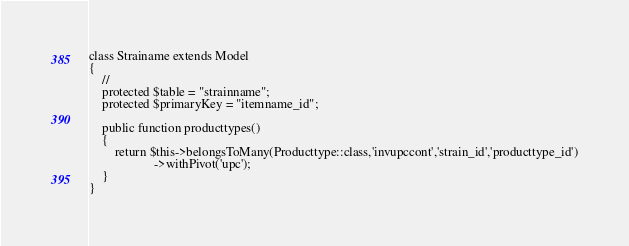Convert code to text. <code><loc_0><loc_0><loc_500><loc_500><_PHP_>class Strainame extends Model
{
    //
    protected $table = "strainname";
    protected $primaryKey = "itemname_id";

    public function producttypes()
    {
        return $this->belongsToMany(Producttype::class,'invupccont','strain_id','producttype_id')
                    ->withPivot('upc');
    }
}
</code> 